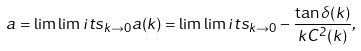<formula> <loc_0><loc_0><loc_500><loc_500>a = \lim \lim i t s _ { k \to 0 } a ( k ) = \lim \lim i t s _ { k \to 0 } - \frac { \tan \delta ( k ) } { k C ^ { 2 } ( k ) } ,</formula> 